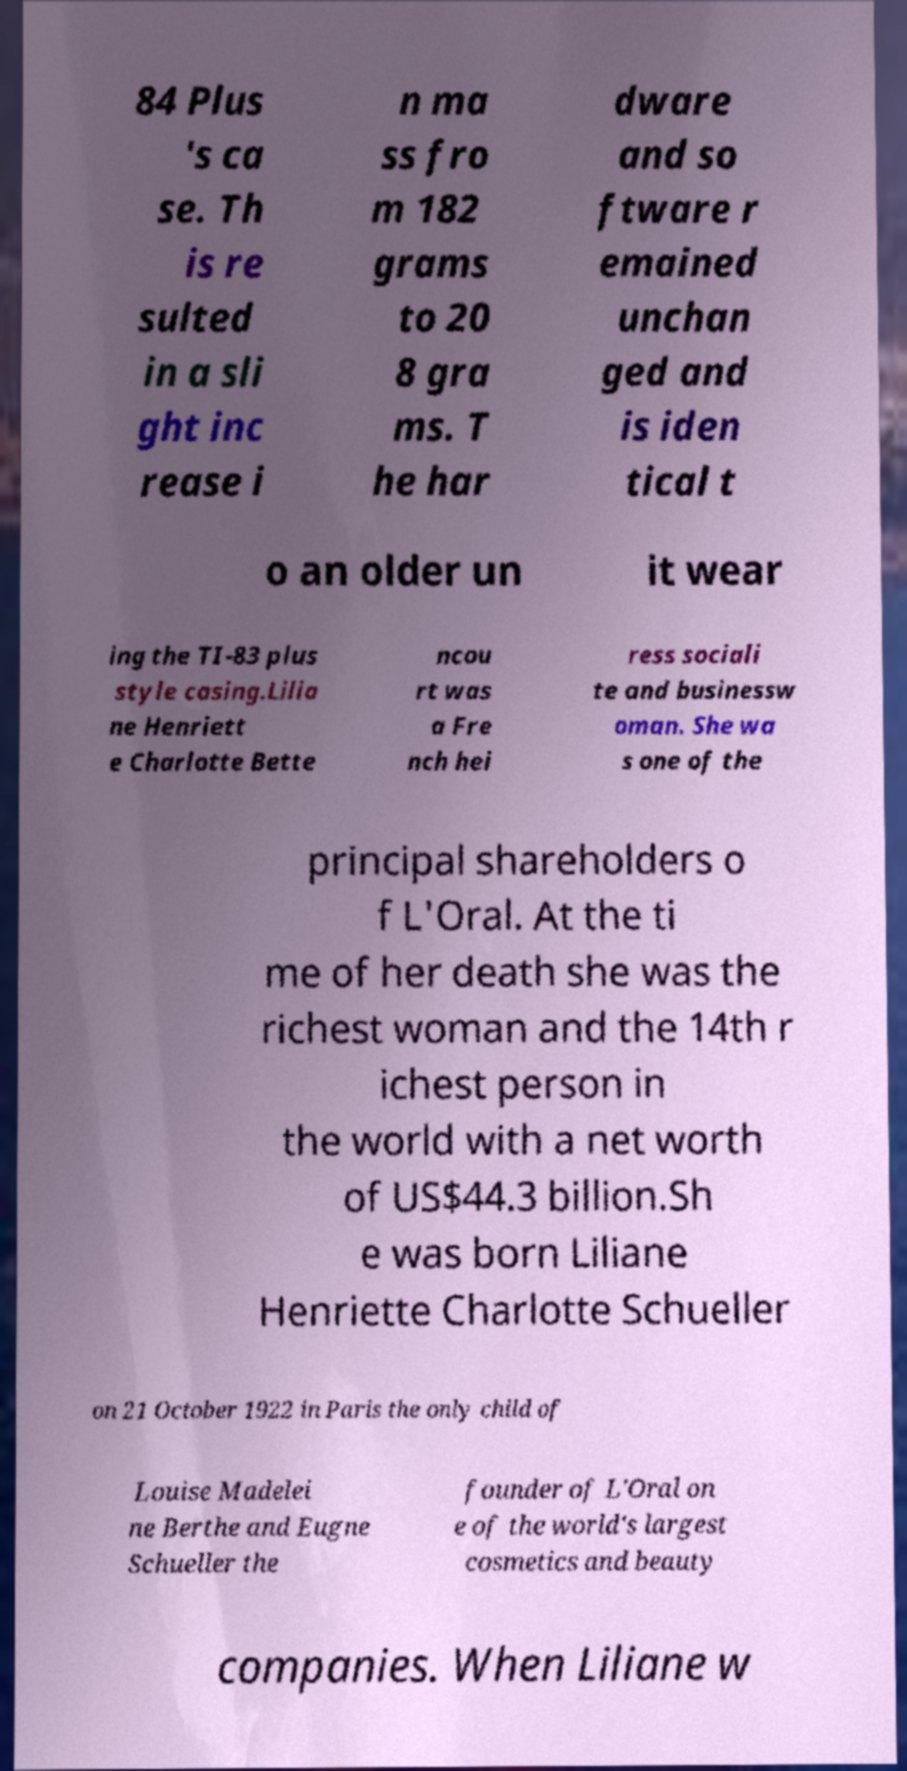Could you assist in decoding the text presented in this image and type it out clearly? 84 Plus 's ca se. Th is re sulted in a sli ght inc rease i n ma ss fro m 182 grams to 20 8 gra ms. T he har dware and so ftware r emained unchan ged and is iden tical t o an older un it wear ing the TI-83 plus style casing.Lilia ne Henriett e Charlotte Bette ncou rt was a Fre nch hei ress sociali te and businessw oman. She wa s one of the principal shareholders o f L'Oral. At the ti me of her death she was the richest woman and the 14th r ichest person in the world with a net worth of US$44.3 billion.Sh e was born Liliane Henriette Charlotte Schueller on 21 October 1922 in Paris the only child of Louise Madelei ne Berthe and Eugne Schueller the founder of L'Oral on e of the world's largest cosmetics and beauty companies. When Liliane w 